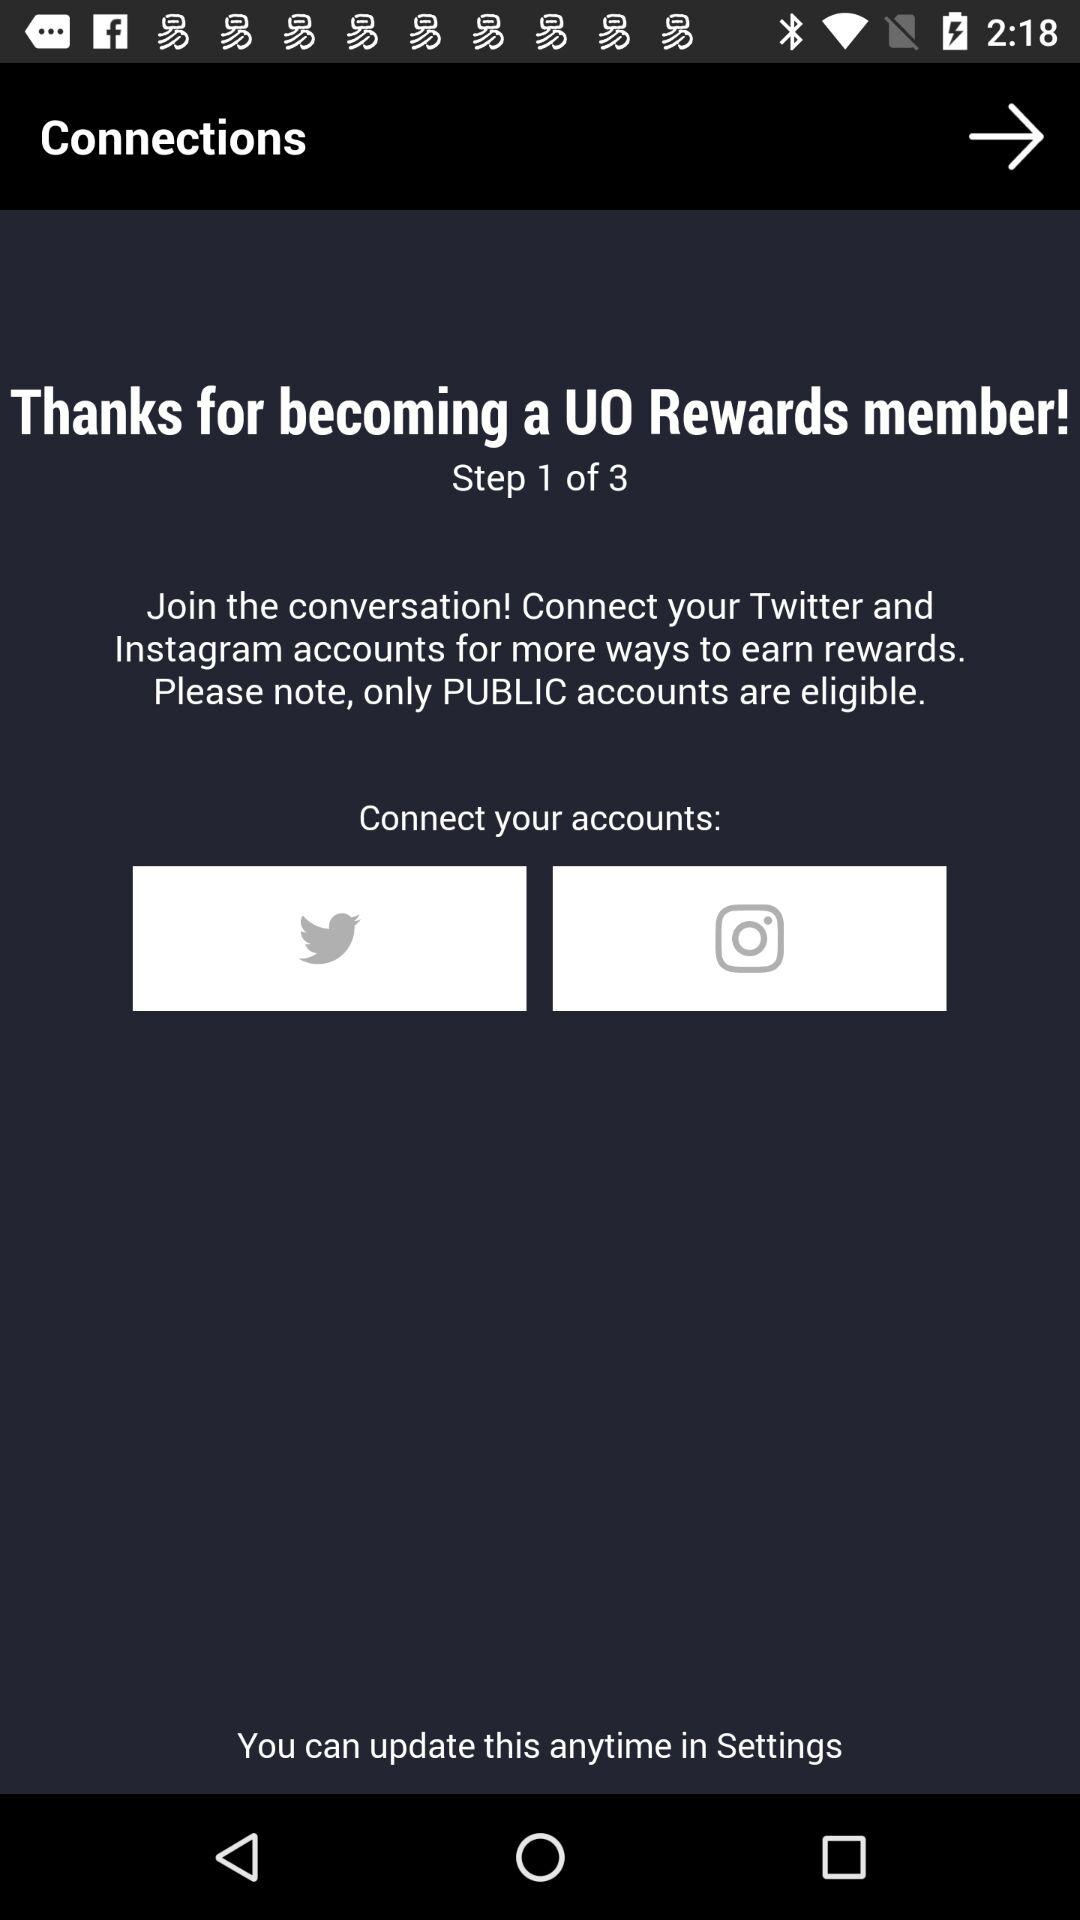Where can the information be updated? The information can be updated in the settings. 